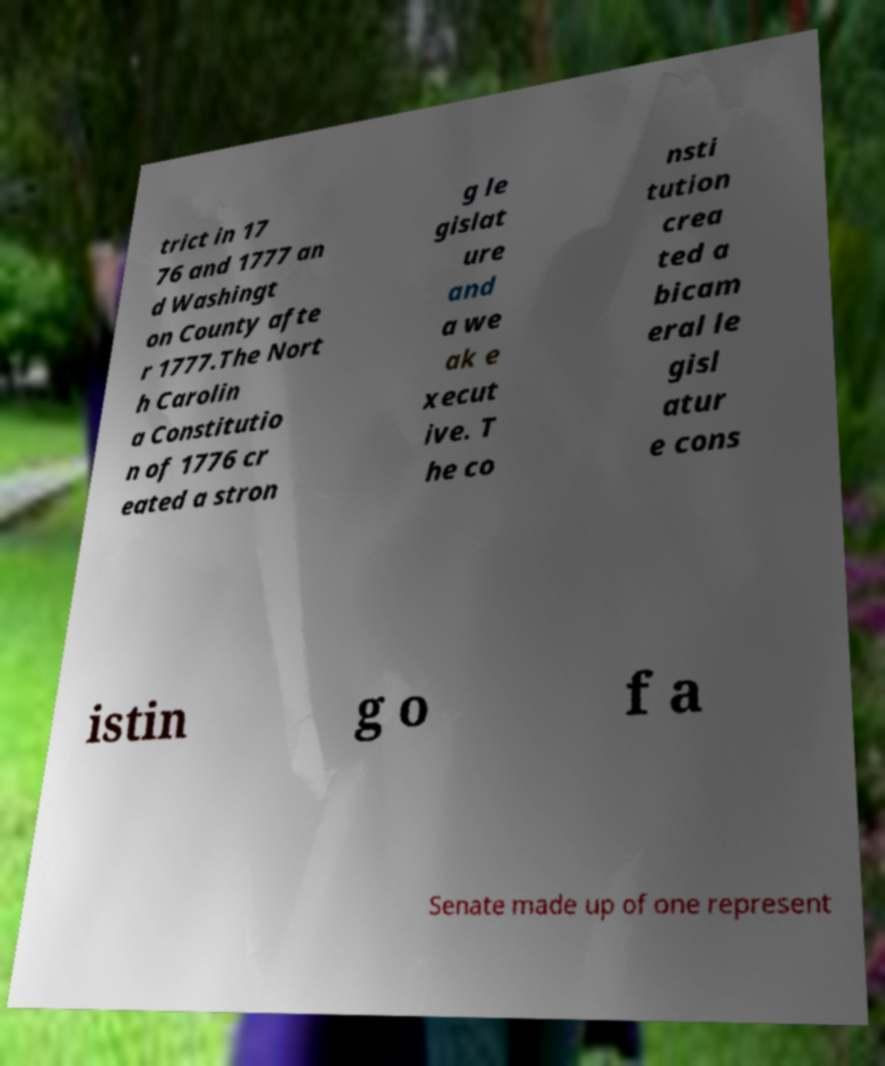Could you extract and type out the text from this image? trict in 17 76 and 1777 an d Washingt on County afte r 1777.The Nort h Carolin a Constitutio n of 1776 cr eated a stron g le gislat ure and a we ak e xecut ive. T he co nsti tution crea ted a bicam eral le gisl atur e cons istin g o f a Senate made up of one represent 